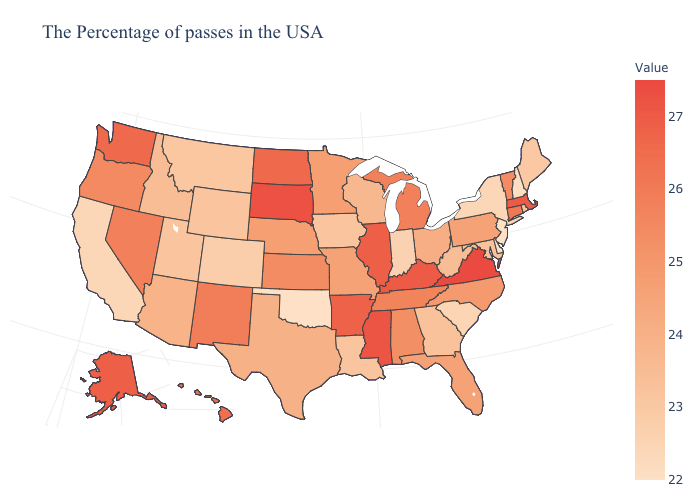Does West Virginia have the highest value in the USA?
Keep it brief. No. Among the states that border Ohio , does Kentucky have the highest value?
Concise answer only. Yes. Does Pennsylvania have the lowest value in the Northeast?
Concise answer only. No. Which states have the highest value in the USA?
Short answer required. Virginia. Does New York have the lowest value in the Northeast?
Write a very short answer. No. 